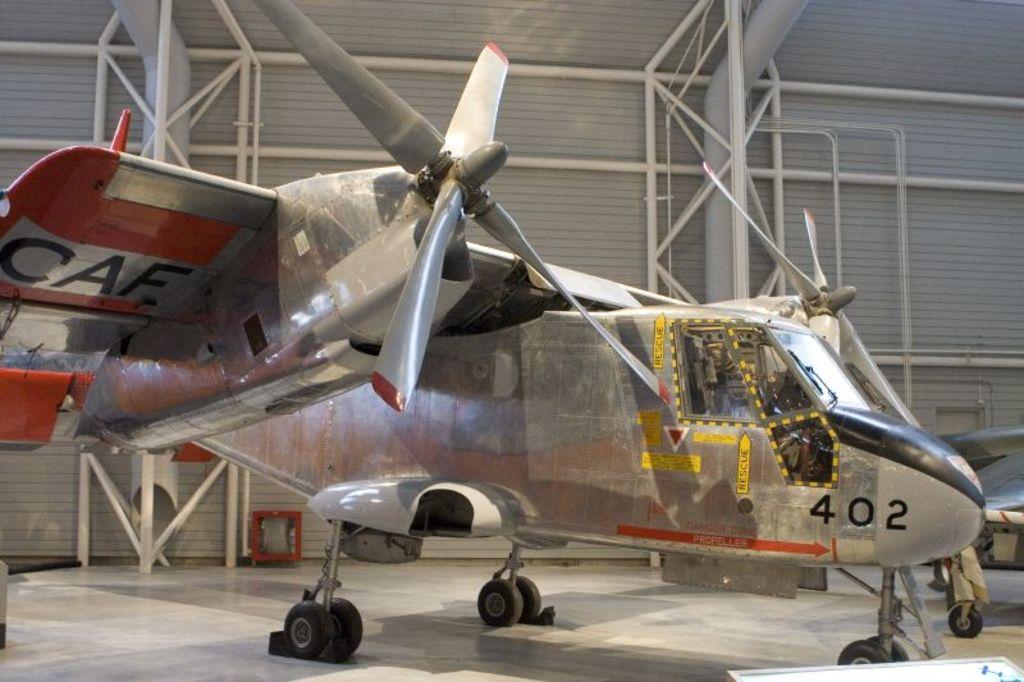What number is on the plane?
Give a very brief answer. 402. 